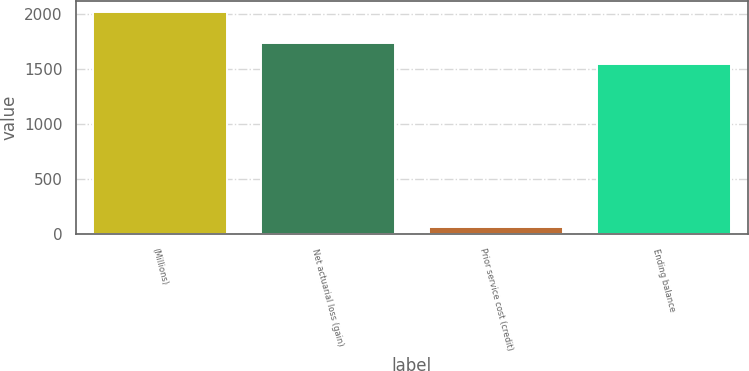Convert chart. <chart><loc_0><loc_0><loc_500><loc_500><bar_chart><fcel>(Millions)<fcel>Net actuarial loss (gain)<fcel>Prior service cost (credit)<fcel>Ending balance<nl><fcel>2015<fcel>1734.7<fcel>68<fcel>1540<nl></chart> 